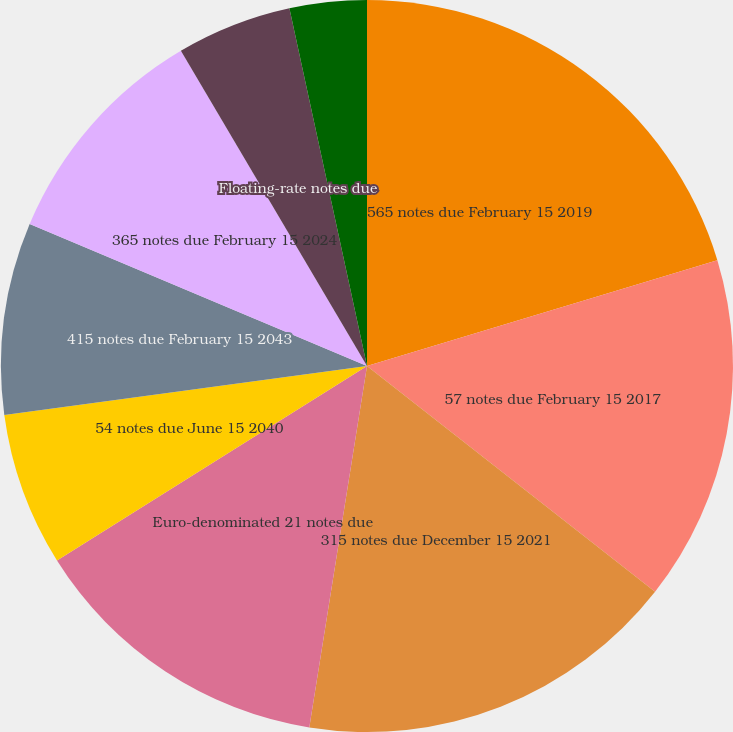Convert chart. <chart><loc_0><loc_0><loc_500><loc_500><pie_chart><fcel>565 notes due February 15 2019<fcel>57 notes due February 15 2017<fcel>315 notes due December 15 2021<fcel>Euro-denominated 21 notes due<fcel>54 notes due June 15 2040<fcel>415 notes due February 15 2043<fcel>365 notes due February 15 2024<fcel>Floating-rate notes due<fcel>0875 notes due January 29 2016<nl><fcel>20.33%<fcel>15.25%<fcel>16.94%<fcel>13.56%<fcel>6.78%<fcel>8.48%<fcel>10.17%<fcel>5.09%<fcel>3.4%<nl></chart> 